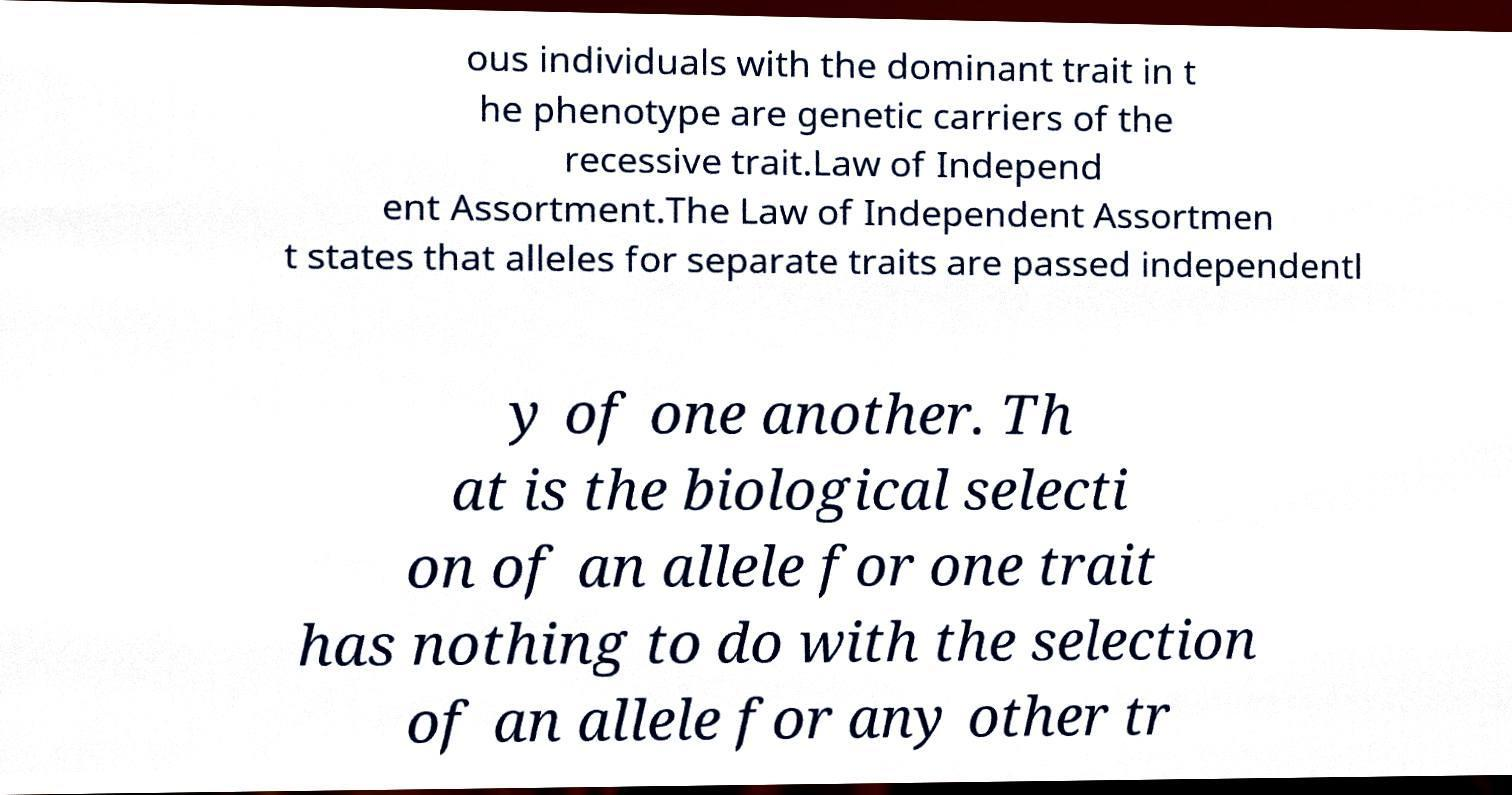Could you extract and type out the text from this image? ous individuals with the dominant trait in t he phenotype are genetic carriers of the recessive trait.Law of Independ ent Assortment.The Law of Independent Assortmen t states that alleles for separate traits are passed independentl y of one another. Th at is the biological selecti on of an allele for one trait has nothing to do with the selection of an allele for any other tr 